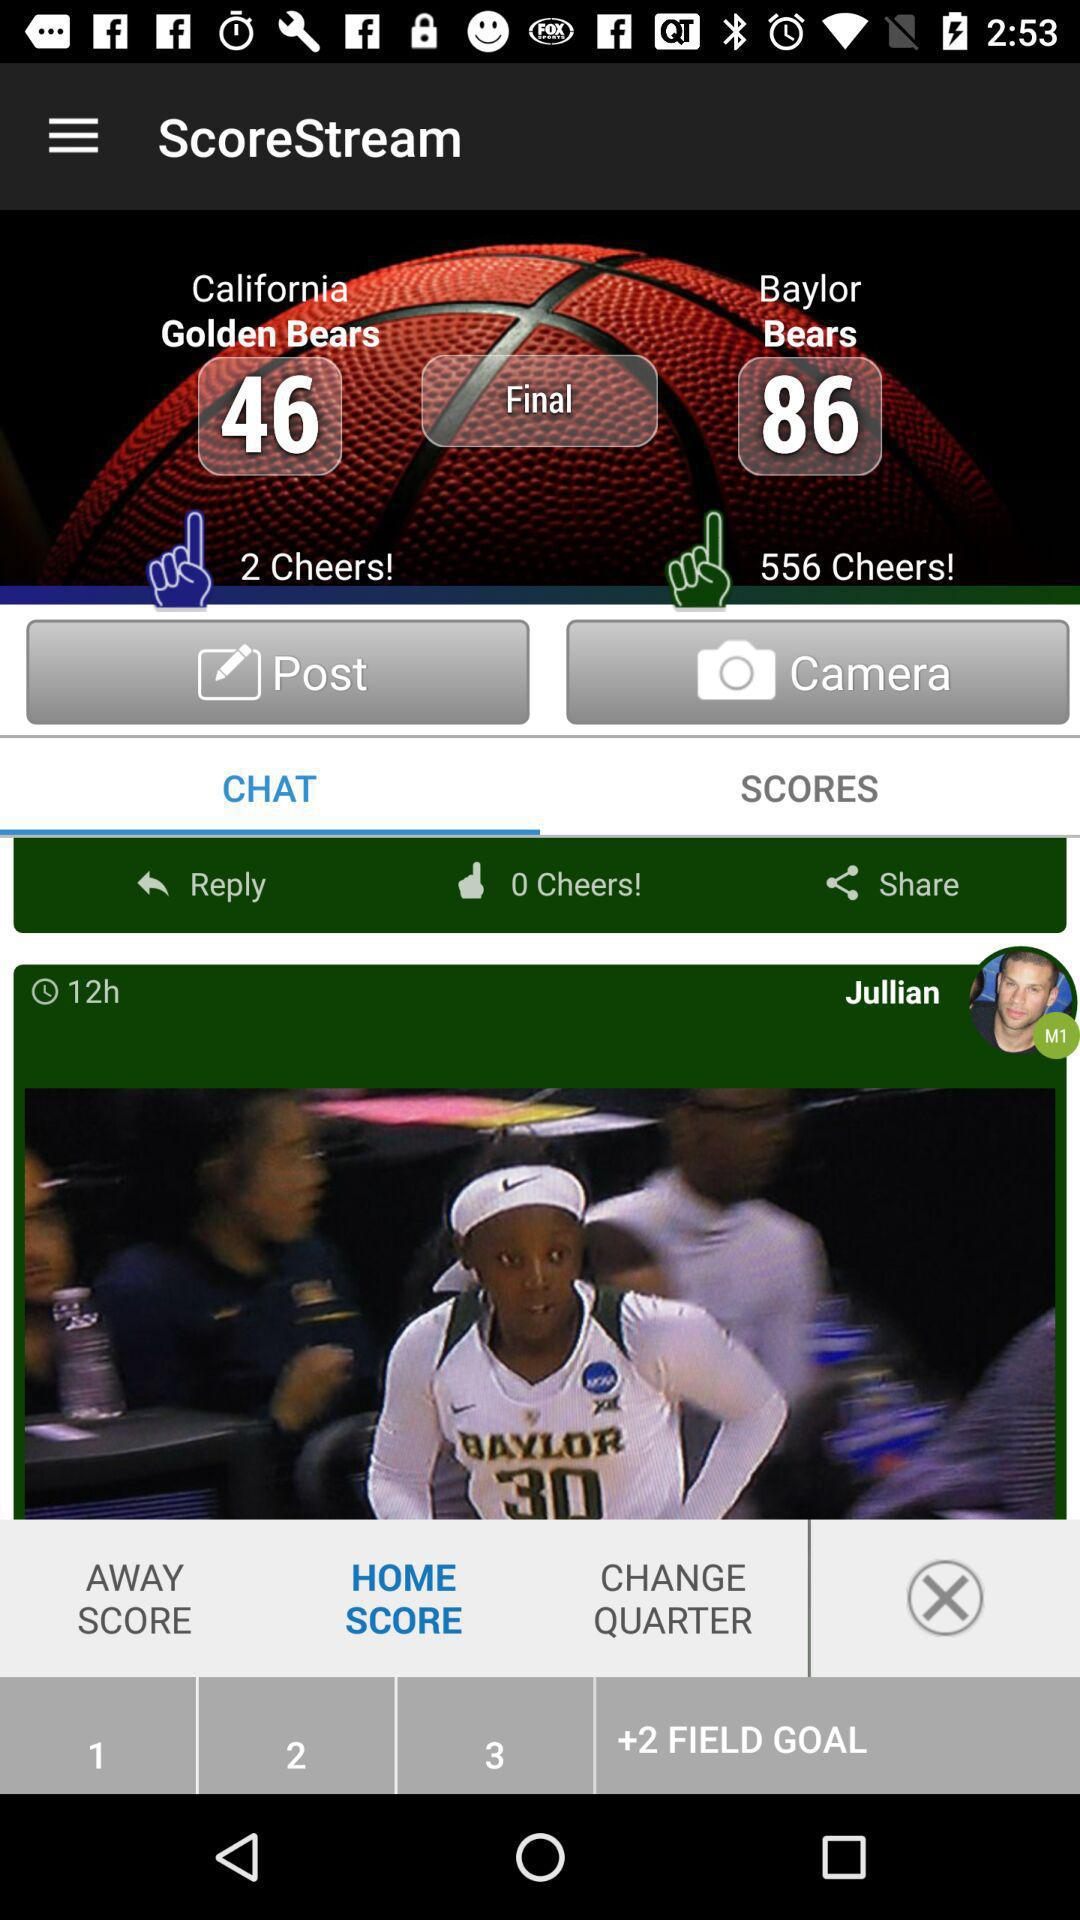How many more cheers does Baylor have than California?
Answer the question using a single word or phrase. 554 